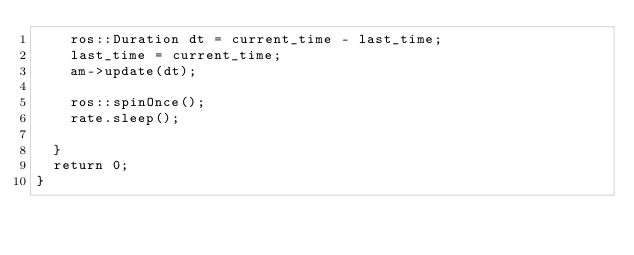<code> <loc_0><loc_0><loc_500><loc_500><_C++_>		ros::Duration dt = current_time - last_time;
		last_time = current_time;
		am->update(dt);

		ros::spinOnce();
		rate.sleep();

	}
	return 0;
}
</code> 